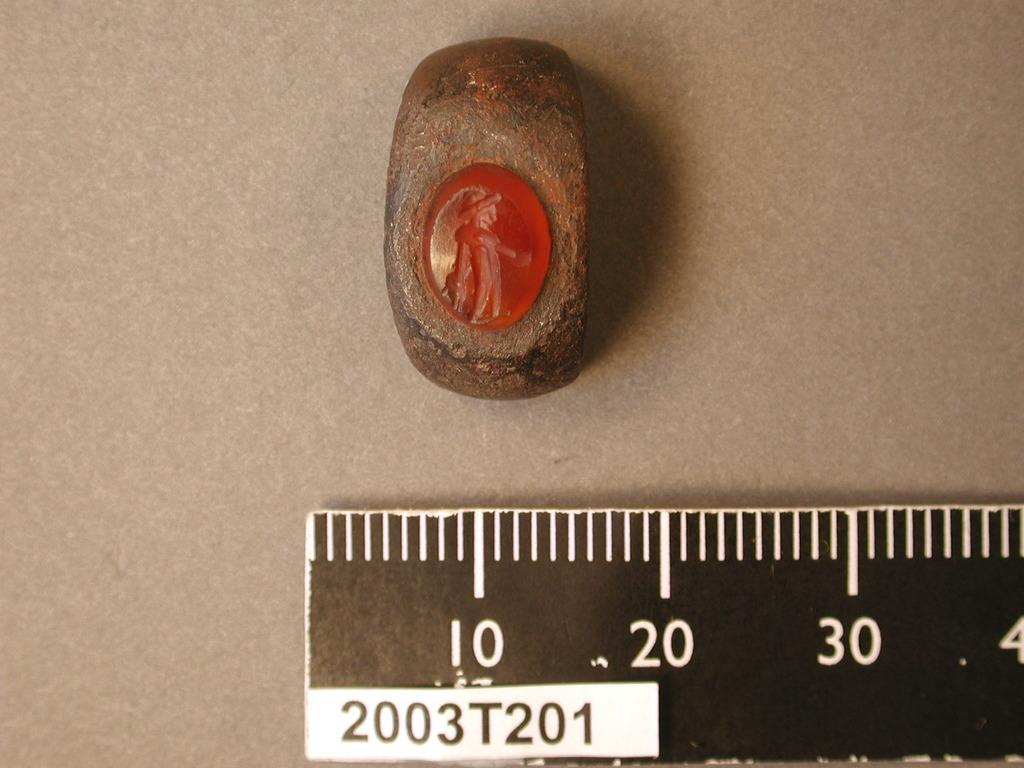<image>
Summarize the visual content of the image. A ruler which has 2003T201 written under the numbers. 